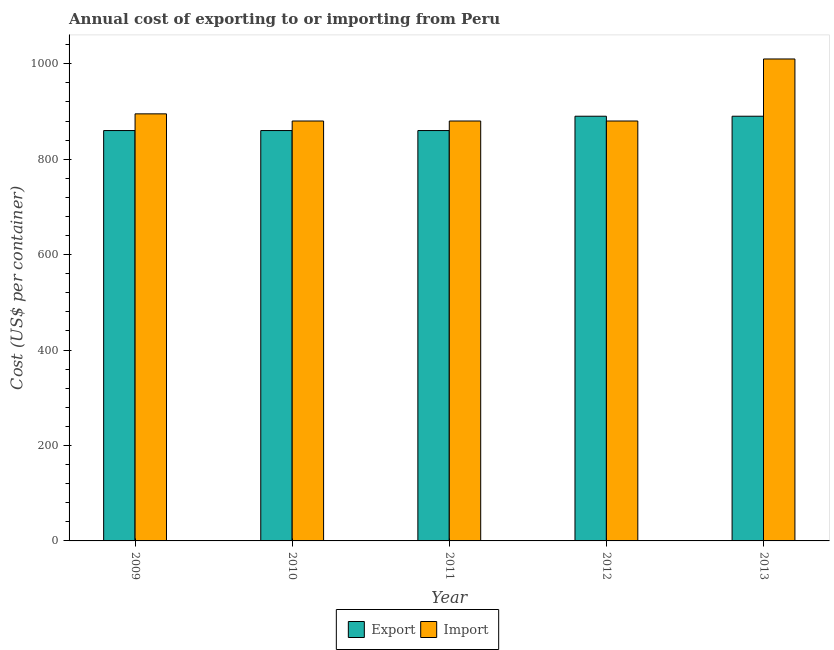Are the number of bars per tick equal to the number of legend labels?
Your response must be concise. Yes. How many bars are there on the 1st tick from the left?
Your response must be concise. 2. How many bars are there on the 2nd tick from the right?
Your answer should be compact. 2. What is the label of the 2nd group of bars from the left?
Keep it short and to the point. 2010. What is the export cost in 2013?
Your answer should be very brief. 890. Across all years, what is the maximum export cost?
Provide a short and direct response. 890. Across all years, what is the minimum import cost?
Offer a terse response. 880. In which year was the import cost minimum?
Your answer should be very brief. 2010. What is the total import cost in the graph?
Your answer should be compact. 4545. What is the difference between the import cost in 2010 and that in 2012?
Your response must be concise. 0. What is the average import cost per year?
Your response must be concise. 909. In how many years, is the import cost greater than 600 US$?
Offer a terse response. 5. What is the ratio of the import cost in 2009 to that in 2013?
Keep it short and to the point. 0.89. Is the difference between the import cost in 2010 and 2013 greater than the difference between the export cost in 2010 and 2013?
Provide a short and direct response. No. What is the difference between the highest and the second highest import cost?
Make the answer very short. 115. What is the difference between the highest and the lowest import cost?
Your answer should be compact. 130. Is the sum of the export cost in 2010 and 2013 greater than the maximum import cost across all years?
Give a very brief answer. Yes. What does the 2nd bar from the left in 2009 represents?
Give a very brief answer. Import. What does the 1st bar from the right in 2012 represents?
Your answer should be very brief. Import. Are all the bars in the graph horizontal?
Your answer should be very brief. No. Does the graph contain grids?
Make the answer very short. No. How are the legend labels stacked?
Your response must be concise. Horizontal. What is the title of the graph?
Your answer should be very brief. Annual cost of exporting to or importing from Peru. What is the label or title of the Y-axis?
Provide a succinct answer. Cost (US$ per container). What is the Cost (US$ per container) in Export in 2009?
Make the answer very short. 860. What is the Cost (US$ per container) in Import in 2009?
Your response must be concise. 895. What is the Cost (US$ per container) in Export in 2010?
Keep it short and to the point. 860. What is the Cost (US$ per container) in Import in 2010?
Provide a succinct answer. 880. What is the Cost (US$ per container) in Export in 2011?
Keep it short and to the point. 860. What is the Cost (US$ per container) of Import in 2011?
Your answer should be compact. 880. What is the Cost (US$ per container) in Export in 2012?
Offer a terse response. 890. What is the Cost (US$ per container) of Import in 2012?
Your answer should be very brief. 880. What is the Cost (US$ per container) of Export in 2013?
Keep it short and to the point. 890. What is the Cost (US$ per container) of Import in 2013?
Keep it short and to the point. 1010. Across all years, what is the maximum Cost (US$ per container) of Export?
Give a very brief answer. 890. Across all years, what is the maximum Cost (US$ per container) of Import?
Keep it short and to the point. 1010. Across all years, what is the minimum Cost (US$ per container) in Export?
Make the answer very short. 860. Across all years, what is the minimum Cost (US$ per container) in Import?
Offer a very short reply. 880. What is the total Cost (US$ per container) in Export in the graph?
Ensure brevity in your answer.  4360. What is the total Cost (US$ per container) in Import in the graph?
Provide a succinct answer. 4545. What is the difference between the Cost (US$ per container) of Import in 2009 and that in 2010?
Offer a terse response. 15. What is the difference between the Cost (US$ per container) of Export in 2009 and that in 2012?
Make the answer very short. -30. What is the difference between the Cost (US$ per container) in Import in 2009 and that in 2012?
Offer a terse response. 15. What is the difference between the Cost (US$ per container) in Import in 2009 and that in 2013?
Your response must be concise. -115. What is the difference between the Cost (US$ per container) of Export in 2010 and that in 2012?
Offer a very short reply. -30. What is the difference between the Cost (US$ per container) of Import in 2010 and that in 2012?
Your answer should be very brief. 0. What is the difference between the Cost (US$ per container) in Export in 2010 and that in 2013?
Your answer should be compact. -30. What is the difference between the Cost (US$ per container) of Import in 2010 and that in 2013?
Provide a succinct answer. -130. What is the difference between the Cost (US$ per container) of Import in 2011 and that in 2013?
Ensure brevity in your answer.  -130. What is the difference between the Cost (US$ per container) in Export in 2012 and that in 2013?
Your answer should be very brief. 0. What is the difference between the Cost (US$ per container) of Import in 2012 and that in 2013?
Offer a very short reply. -130. What is the difference between the Cost (US$ per container) in Export in 2009 and the Cost (US$ per container) in Import in 2010?
Your answer should be compact. -20. What is the difference between the Cost (US$ per container) of Export in 2009 and the Cost (US$ per container) of Import in 2013?
Offer a very short reply. -150. What is the difference between the Cost (US$ per container) in Export in 2010 and the Cost (US$ per container) in Import in 2013?
Give a very brief answer. -150. What is the difference between the Cost (US$ per container) in Export in 2011 and the Cost (US$ per container) in Import in 2012?
Offer a very short reply. -20. What is the difference between the Cost (US$ per container) in Export in 2011 and the Cost (US$ per container) in Import in 2013?
Ensure brevity in your answer.  -150. What is the difference between the Cost (US$ per container) of Export in 2012 and the Cost (US$ per container) of Import in 2013?
Your answer should be very brief. -120. What is the average Cost (US$ per container) in Export per year?
Your answer should be compact. 872. What is the average Cost (US$ per container) in Import per year?
Offer a very short reply. 909. In the year 2009, what is the difference between the Cost (US$ per container) in Export and Cost (US$ per container) in Import?
Your answer should be compact. -35. In the year 2012, what is the difference between the Cost (US$ per container) in Export and Cost (US$ per container) in Import?
Ensure brevity in your answer.  10. In the year 2013, what is the difference between the Cost (US$ per container) of Export and Cost (US$ per container) of Import?
Offer a terse response. -120. What is the ratio of the Cost (US$ per container) of Export in 2009 to that in 2010?
Offer a very short reply. 1. What is the ratio of the Cost (US$ per container) of Export in 2009 to that in 2012?
Your response must be concise. 0.97. What is the ratio of the Cost (US$ per container) of Export in 2009 to that in 2013?
Offer a terse response. 0.97. What is the ratio of the Cost (US$ per container) in Import in 2009 to that in 2013?
Your response must be concise. 0.89. What is the ratio of the Cost (US$ per container) in Import in 2010 to that in 2011?
Give a very brief answer. 1. What is the ratio of the Cost (US$ per container) of Export in 2010 to that in 2012?
Your answer should be compact. 0.97. What is the ratio of the Cost (US$ per container) of Export in 2010 to that in 2013?
Make the answer very short. 0.97. What is the ratio of the Cost (US$ per container) of Import in 2010 to that in 2013?
Your answer should be very brief. 0.87. What is the ratio of the Cost (US$ per container) of Export in 2011 to that in 2012?
Provide a succinct answer. 0.97. What is the ratio of the Cost (US$ per container) of Export in 2011 to that in 2013?
Offer a terse response. 0.97. What is the ratio of the Cost (US$ per container) in Import in 2011 to that in 2013?
Provide a short and direct response. 0.87. What is the ratio of the Cost (US$ per container) in Export in 2012 to that in 2013?
Your response must be concise. 1. What is the ratio of the Cost (US$ per container) of Import in 2012 to that in 2013?
Your answer should be compact. 0.87. What is the difference between the highest and the second highest Cost (US$ per container) of Export?
Offer a very short reply. 0. What is the difference between the highest and the second highest Cost (US$ per container) in Import?
Offer a very short reply. 115. What is the difference between the highest and the lowest Cost (US$ per container) of Import?
Your response must be concise. 130. 